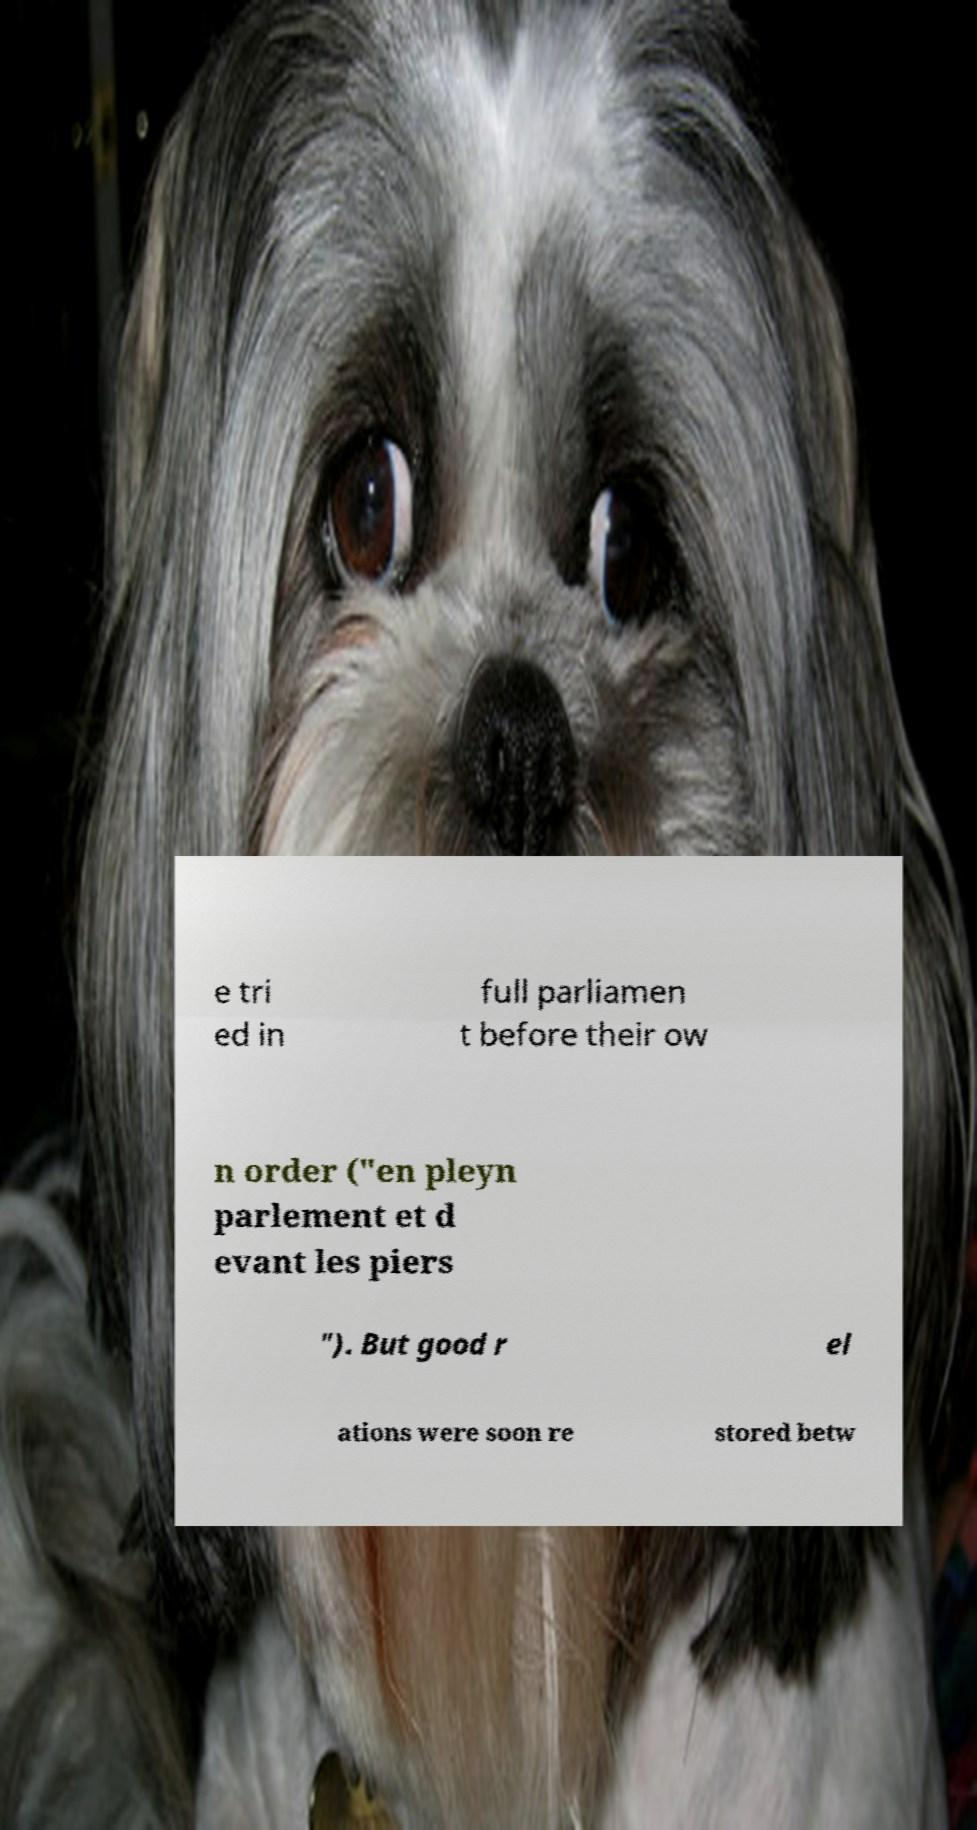Can you read and provide the text displayed in the image?This photo seems to have some interesting text. Can you extract and type it out for me? e tri ed in full parliamen t before their ow n order ("en pleyn parlement et d evant les piers "). But good r el ations were soon re stored betw 